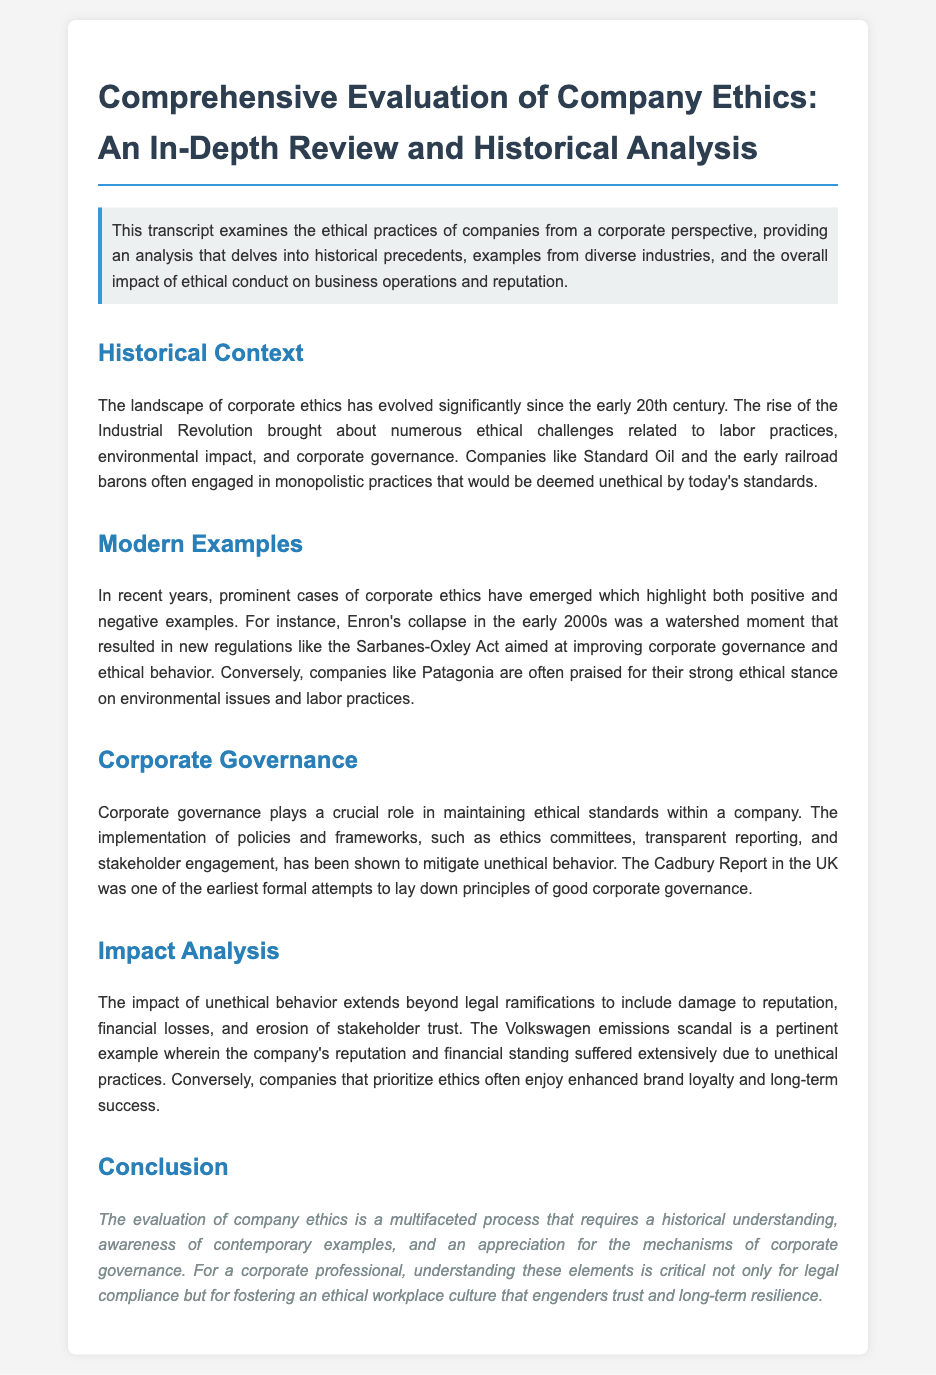what major event in corporate ethics is associated with Enron? Enron's collapse in the early 2000s was a watershed moment that impacted corporate governance regulation.
Answer: Enron's collapse what act was introduced following the Enron scandal? The Sarbanes-Oxley Act was aimed at improving corporate governance and ethical behavior after the Enron scandal.
Answer: Sarbanes-Oxley Act which company is praised for its strong ethical stance on environmental issues? Patagonia is often cited for its commendable practices relating to ethics, particularly in environmental and labor areas.
Answer: Patagonia what was one of the earliest attempts to establish corporate governance principles? The Cadbury Report in the UK laid down principles of good corporate governance in an early formal attempt.
Answer: Cadbury Report how does unethical behavior impact a company beyond legal ramifications? Unethical behavior leads to damage to reputation, financial losses, and erosion of stakeholder trust.
Answer: Damage to reputation what was a significant consequence of the Volkswagen emissions scandal? The Volkswagen emissions scandal resulted in the company's reputation and financial standing suffering extensively due to unethical practices.
Answer: Suffering of reputation and financial standing what key aspect ensures a company's ethical standards? Corporate governance plays a crucial role in maintaining ethical standards within a company.
Answer: Corporate governance when did the Industrial Revolution begin to influence corporate ethics? The early 20th century marked the significant evolution of corporate ethics influenced by the Industrial Revolution.
Answer: Early 20th century 